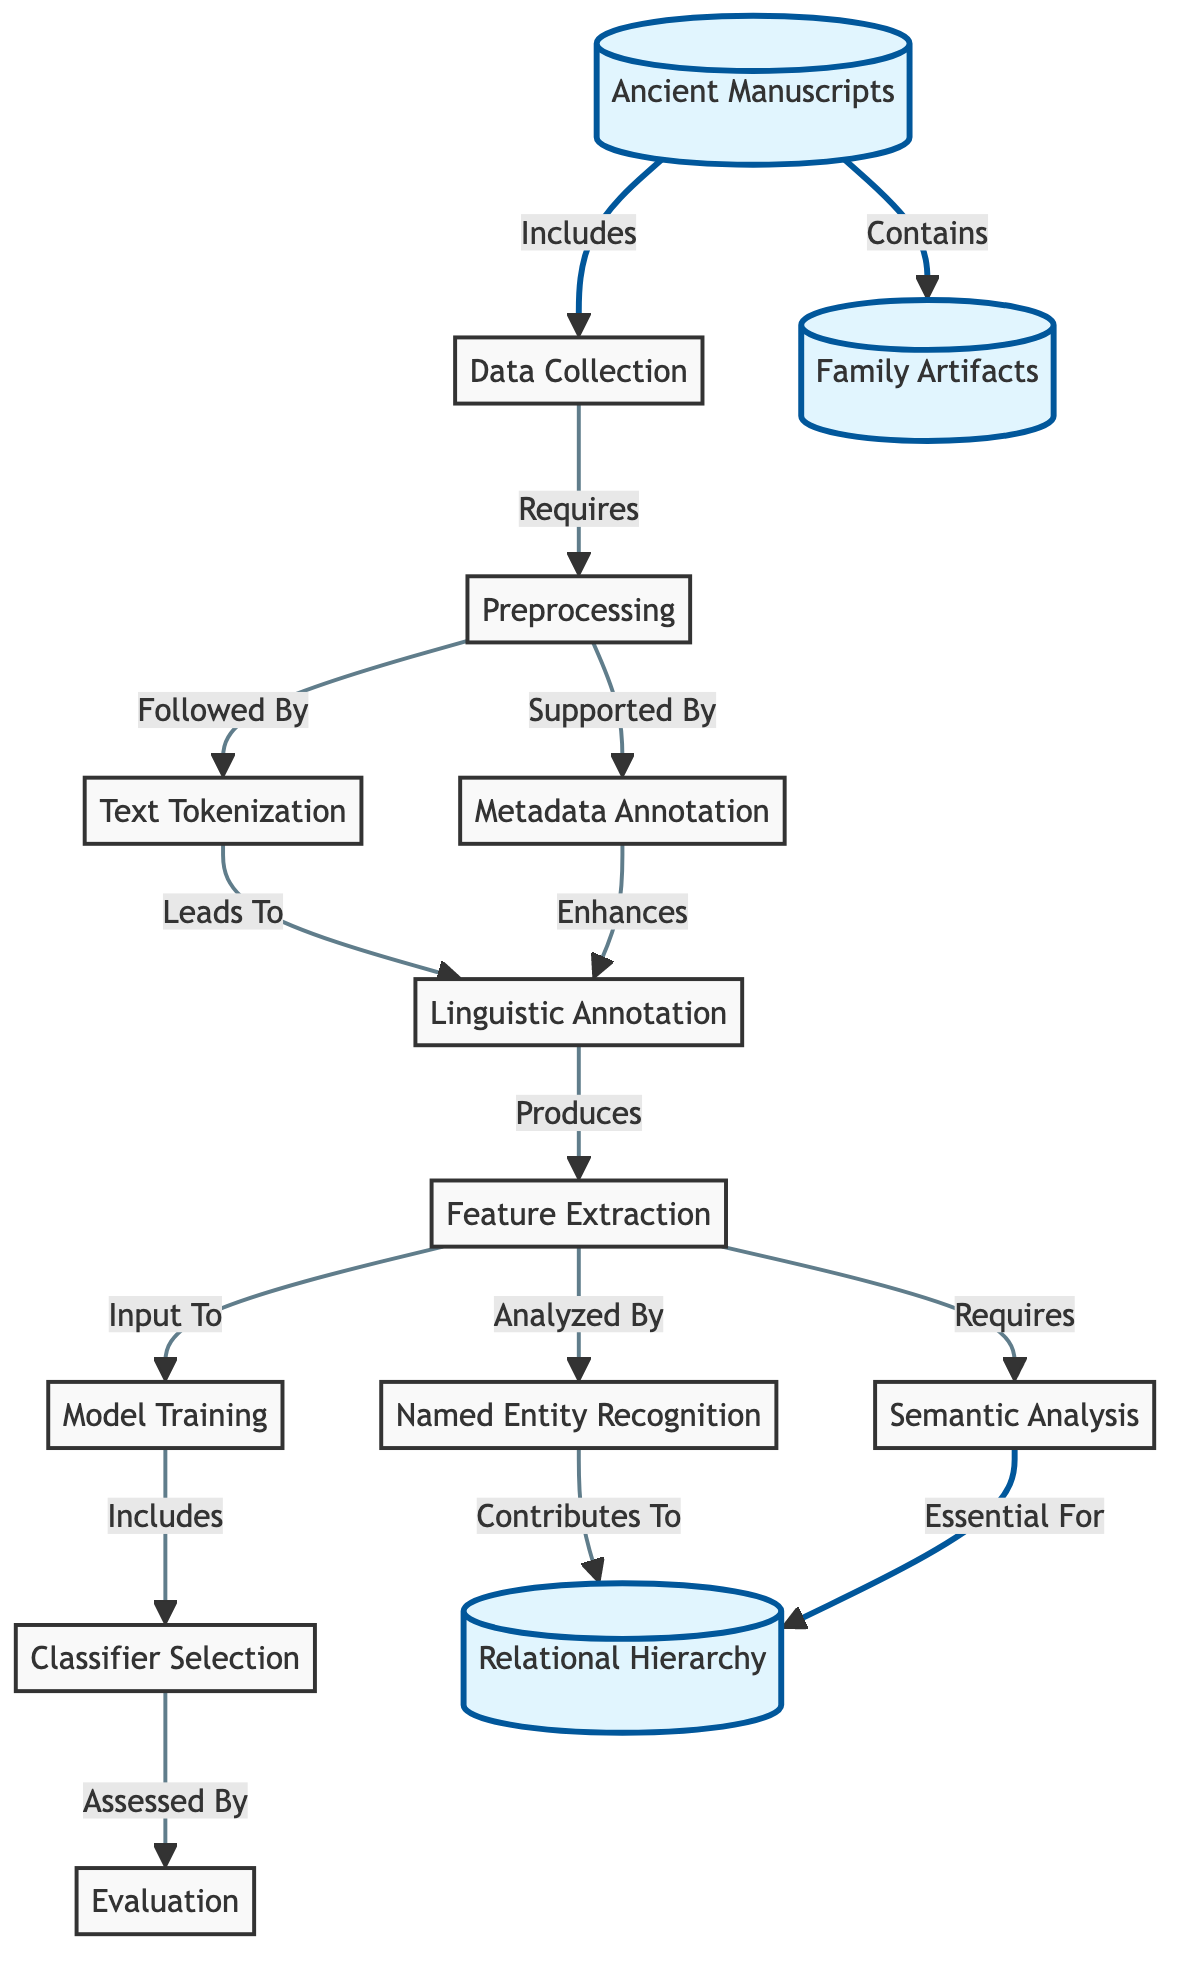What is the initial node in the diagram? The diagram starts with the node labeled "Ancient Manuscripts," which is the primary focus of the entire process.
Answer: Ancient Manuscripts How many nodes are present in the diagram? By counting each unique element, the total number of nodes in the diagram sums up to 14.
Answer: 14 What type of analysis is essential for the relational hierarchy according to the diagram? The diagram specifies that "Semantic Analysis" is crucial, as it feeds into the relational hierarchy connection.
Answer: Semantic Analysis Which step follows "Preprocessing" in the flow of the diagram? The diagram indicates that after "Preprocessing," the next step is labeled "Text Tokenization."
Answer: Text Tokenization What two processes contribute to the "Relational Hierarchy"? According to the diagram, both "Named Entity Recognition" and "Semantic Analysis" feed into the "Relational Hierarchy."
Answer: Named Entity Recognition, Semantic Analysis Which node improves the "Linguistic Annotation"? "Metadata Annotation" is indicated as supporting the "Linguistic Annotation" process in the diagram, enhancing its quality.
Answer: Metadata Annotation What is the role of "Feature Extraction" in the text classification process? The "Feature Extraction" node is seen as producing inputs for the "Model Training," indicating it is critical for preparing data for training purposes.
Answer: Input to Model Training What process is assessed by the "Evaluation" node? The diagram clearly shows that "Model Training" is the process being evaluated to determine its effectiveness and performance.
Answer: Model Training Which element includes "Family Artifacts"? The diagram states that "Ancient Manuscripts" contain "Family Artifacts," indicating a direct relationship between these two nodes.
Answer: Family Artifacts 